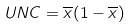<formula> <loc_0><loc_0><loc_500><loc_500>U N C = \overline { x } ( 1 - \overline { x } )</formula> 